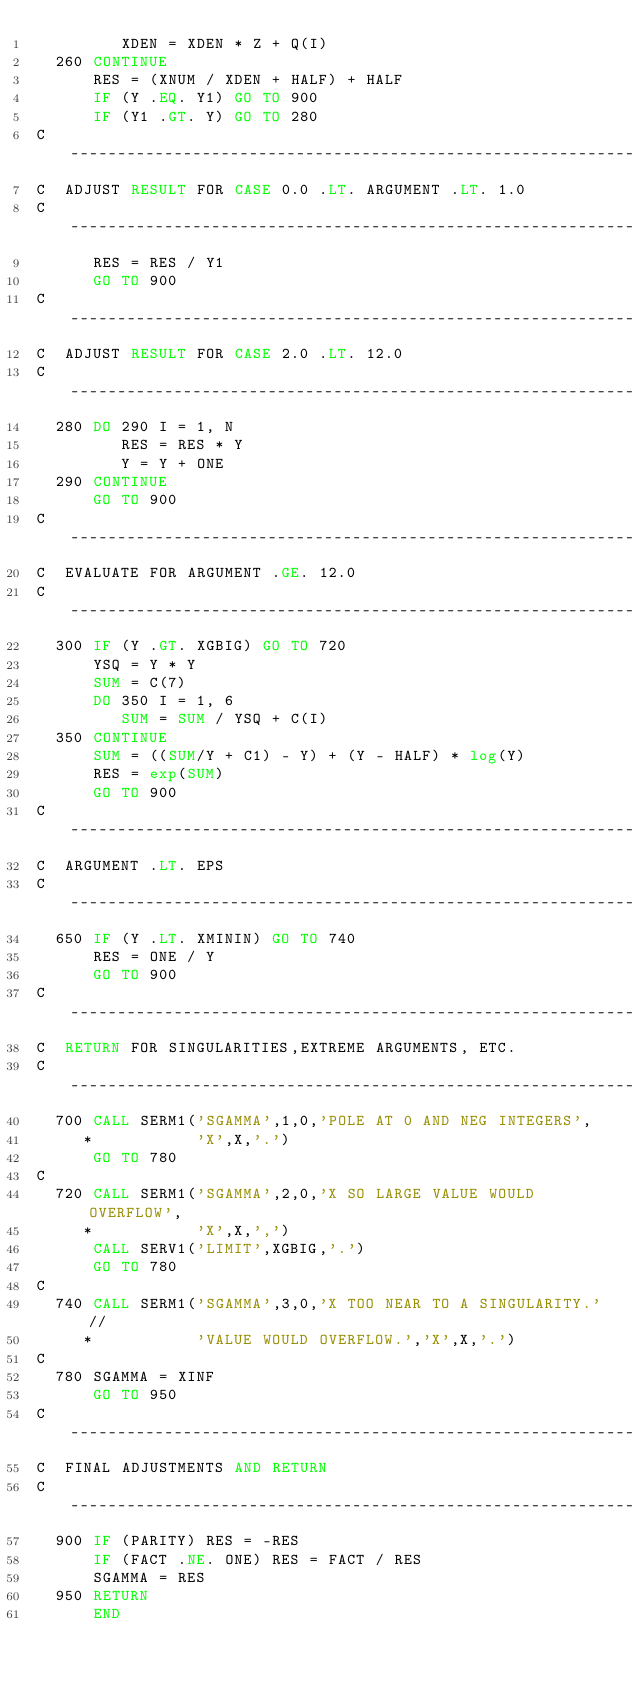Convert code to text. <code><loc_0><loc_0><loc_500><loc_500><_FORTRAN_>         XDEN = XDEN * Z + Q(I)
  260 CONTINUE
      RES = (XNUM / XDEN + HALF) + HALF
      IF (Y .EQ. Y1) GO TO 900
      IF (Y1 .GT. Y) GO TO 280
C ----------------------------------------------------------------------
C  ADJUST RESULT FOR CASE 0.0 .LT. ARGUMENT .LT. 1.0
C ----------------------------------------------------------------------
      RES = RES / Y1
      GO TO 900
C ----------------------------------------------------------------------
C  ADJUST RESULT FOR CASE 2.0 .LT. 12.0
C ----------------------------------------------------------------------
  280 DO 290 I = 1, N
         RES = RES * Y
         Y = Y + ONE
  290 CONTINUE
      GO TO 900
C ----------------------------------------------------------------------
C  EVALUATE FOR ARGUMENT .GE. 12.0
C ----------------------------------------------------------------------
  300 IF (Y .GT. XGBIG) GO TO 720
      YSQ = Y * Y
      SUM = C(7)
      DO 350 I = 1, 6
         SUM = SUM / YSQ + C(I)
  350 CONTINUE
      SUM = ((SUM/Y + C1) - Y) + (Y - HALF) * log(Y)
      RES = exp(SUM)
      GO TO 900
C ----------------------------------------------------------------------
C  ARGUMENT .LT. EPS
C ----------------------------------------------------------------------
  650 IF (Y .LT. XMININ) GO TO 740
      RES = ONE / Y
      GO TO 900
C ----------------------------------------------------------------------
C  RETURN FOR SINGULARITIES,EXTREME ARGUMENTS, ETC.
C ----------------------------------------------------------------------
  700 CALL SERM1('SGAMMA',1,0,'POLE AT 0 AND NEG INTEGERS',
     *           'X',X,'.')
      GO TO 780
C
  720 CALL SERM1('SGAMMA',2,0,'X SO LARGE VALUE WOULD OVERFLOW',
     *           'X',X,',')
      CALL SERV1('LIMIT',XGBIG,'.')
      GO TO 780
C
  740 CALL SERM1('SGAMMA',3,0,'X TOO NEAR TO A SINGULARITY.'//
     *           'VALUE WOULD OVERFLOW.','X',X,'.')
C
  780 SGAMMA = XINF
      GO TO 950
C ----------------------------------------------------------------------
C  FINAL ADJUSTMENTS AND RETURN
C ----------------------------------------------------------------------
  900 IF (PARITY) RES = -RES
      IF (FACT .NE. ONE) RES = FACT / RES
      SGAMMA = RES
  950 RETURN
      END
</code> 